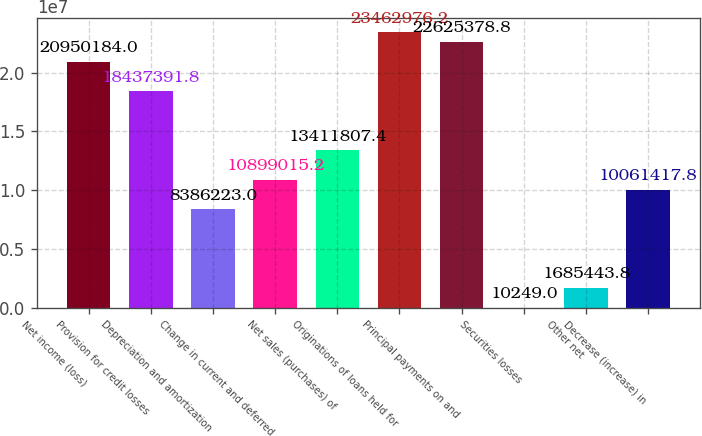Convert chart to OTSL. <chart><loc_0><loc_0><loc_500><loc_500><bar_chart><fcel>Net income (loss)<fcel>Provision for credit losses<fcel>Depreciation and amortization<fcel>Change in current and deferred<fcel>Net sales (purchases) of<fcel>Originations of loans held for<fcel>Principal payments on and<fcel>Securities losses<fcel>Other net<fcel>Decrease (increase) in<nl><fcel>2.09502e+07<fcel>1.84374e+07<fcel>8.38622e+06<fcel>1.0899e+07<fcel>1.34118e+07<fcel>2.3463e+07<fcel>2.26254e+07<fcel>10249<fcel>1.68544e+06<fcel>1.00614e+07<nl></chart> 